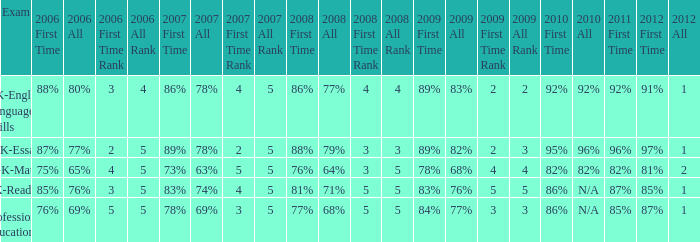What is the percentage for all 2008 when all in 2007 is 69%? 68%. 